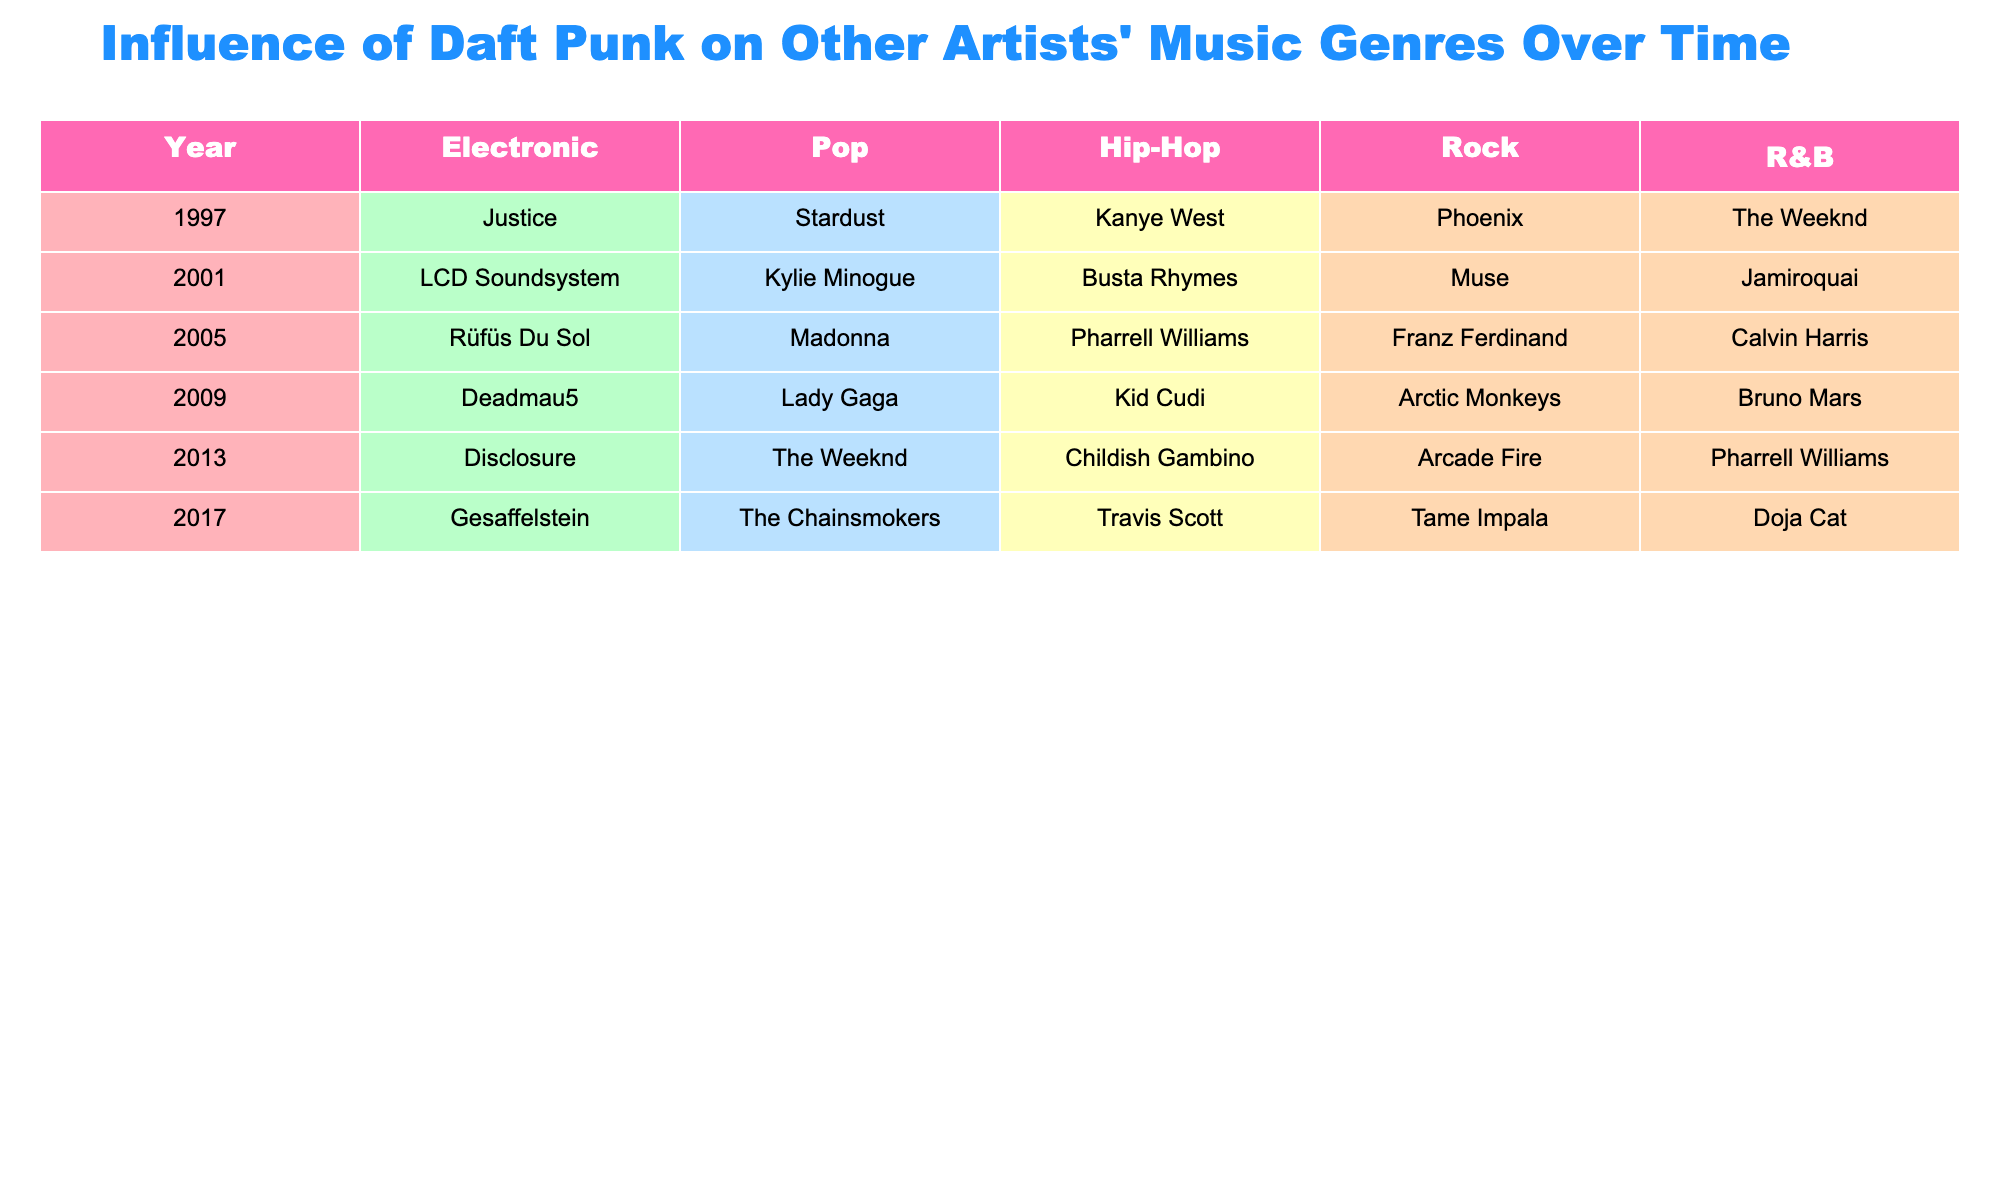What artist in the Hip-Hop genre was influenced by Daft Punk in 2009? The table indicates that in 2009, Kid Cudi is listed under the Hip-Hop genre.
Answer: Kid Cudi Which Pop artist appears in the table for the year 2013? From the table, in 2013, The Weeknd is listed under the Pop genre.
Answer: The Weeknd What is the total number of genres represented in the table? The table includes five genres: Electronic, Pop, Hip-Hop, Rock, and R&B. Thus, the total is 5.
Answer: 5 Which artist is listed under the R&B genre in 2017? The table shows that Doja Cat is the only artist listed under the R&B genre in 2017.
Answer: Doja Cat In what year did Kanye West get influenced by Daft Punk? According to the table, Kanye West appears in the Hip-Hop category in 1997.
Answer: 1997 Who are the artists that appeared in the Electronic genre from 2001 to 2017? The Electronic artists from 2001 to 2017 are LCD Soundsystem (2001), Rüfüs Du Sol (2005), Deadmau5 (2009), Disclosure (2013), and Gesaffelstein (2017).
Answer: LCD Soundsystem, Rüfüs Du Sol, Deadmau5, Disclosure, Gesaffelstein In which year did R&B influence include Calvin Harris? The table shows Calvin Harris was influenced by Daft Punk in 2005 within the R&B genre category.
Answer: 2005 What is the difference in the number of influences in the Rock genre between 2005 and 2013? In 2005, Franz Ferdinand is in Rock, and in 2013, Arcade Fire is listed. Therefore, the difference is 1 influence (both years have 1 influence).
Answer: 0 Which genre saw the most variety of artists across the years in the table? By reviewing the years, the genres with multiple different artists over the range are R&B and Pop, appearing in every year listed, indicating a higher variety.
Answer: R&B and Pop Was Deadmau5 the only Electronic artist influenced by Daft Punk in 2009? According to the table, Deadmau5 is listed as the only Electronic artist in 2009, confirming the fact.
Answer: Yes In how many years was Pharrell Williams influenced across different genres? Pharrell Williams appears in the table for the R&B genre in 2005 and 2013, showing influence in 2 different years.
Answer: 2 